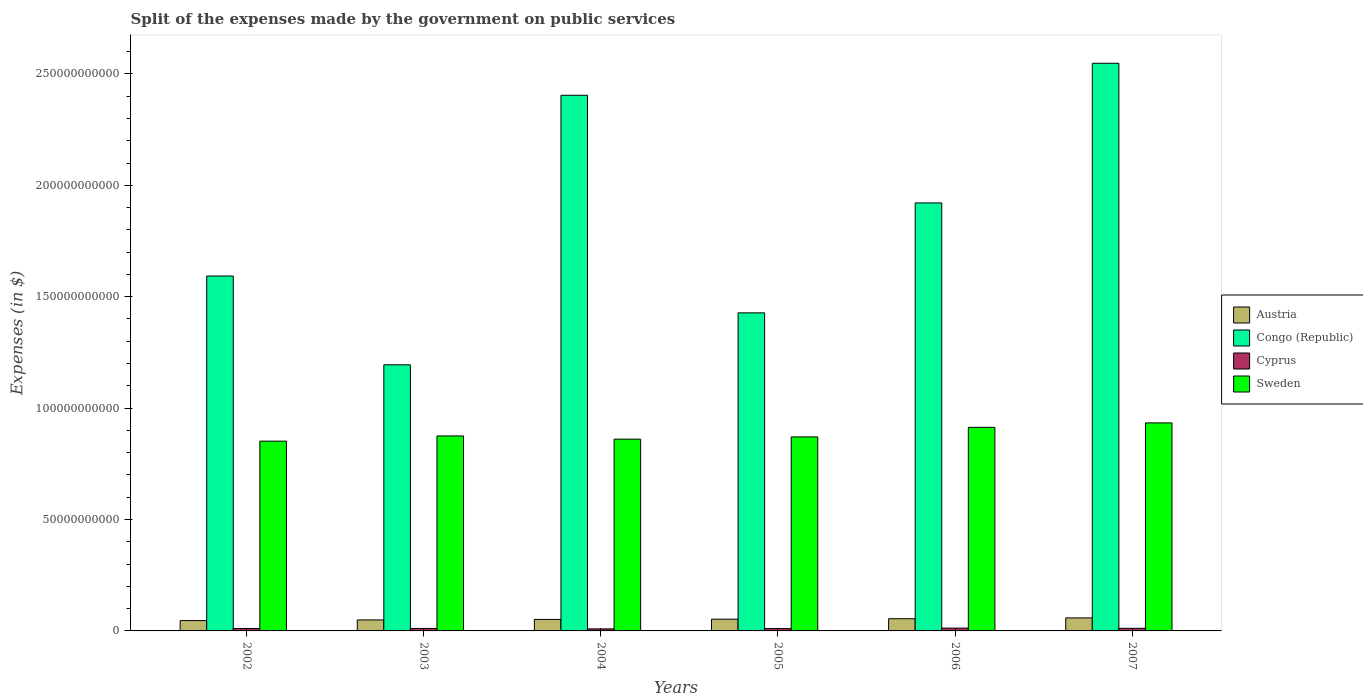How many different coloured bars are there?
Your response must be concise. 4. Are the number of bars on each tick of the X-axis equal?
Offer a very short reply. Yes. How many bars are there on the 1st tick from the left?
Provide a short and direct response. 4. What is the label of the 1st group of bars from the left?
Offer a terse response. 2002. What is the expenses made by the government on public services in Sweden in 2002?
Provide a succinct answer. 8.52e+1. Across all years, what is the maximum expenses made by the government on public services in Congo (Republic)?
Offer a terse response. 2.55e+11. Across all years, what is the minimum expenses made by the government on public services in Austria?
Provide a short and direct response. 4.65e+09. In which year was the expenses made by the government on public services in Austria minimum?
Keep it short and to the point. 2002. What is the total expenses made by the government on public services in Cyprus in the graph?
Provide a succinct answer. 6.59e+09. What is the difference between the expenses made by the government on public services in Cyprus in 2005 and that in 2006?
Your answer should be very brief. -2.13e+08. What is the difference between the expenses made by the government on public services in Cyprus in 2005 and the expenses made by the government on public services in Austria in 2004?
Offer a very short reply. -4.11e+09. What is the average expenses made by the government on public services in Congo (Republic) per year?
Provide a succinct answer. 1.85e+11. In the year 2004, what is the difference between the expenses made by the government on public services in Sweden and expenses made by the government on public services in Cyprus?
Make the answer very short. 8.51e+1. In how many years, is the expenses made by the government on public services in Cyprus greater than 110000000000 $?
Your answer should be compact. 0. What is the ratio of the expenses made by the government on public services in Sweden in 2002 to that in 2004?
Make the answer very short. 0.99. What is the difference between the highest and the second highest expenses made by the government on public services in Congo (Republic)?
Offer a terse response. 1.44e+1. What is the difference between the highest and the lowest expenses made by the government on public services in Cyprus?
Your answer should be very brief. 3.38e+08. Is the sum of the expenses made by the government on public services in Cyprus in 2003 and 2006 greater than the maximum expenses made by the government on public services in Congo (Republic) across all years?
Your answer should be very brief. No. What does the 3rd bar from the left in 2007 represents?
Your response must be concise. Cyprus. What does the 1st bar from the right in 2007 represents?
Make the answer very short. Sweden. What is the difference between two consecutive major ticks on the Y-axis?
Provide a short and direct response. 5.00e+1. Does the graph contain any zero values?
Offer a very short reply. No. Where does the legend appear in the graph?
Offer a terse response. Center right. How many legend labels are there?
Provide a succinct answer. 4. How are the legend labels stacked?
Provide a short and direct response. Vertical. What is the title of the graph?
Provide a succinct answer. Split of the expenses made by the government on public services. What is the label or title of the X-axis?
Your answer should be compact. Years. What is the label or title of the Y-axis?
Keep it short and to the point. Expenses (in $). What is the Expenses (in $) of Austria in 2002?
Offer a very short reply. 4.65e+09. What is the Expenses (in $) of Congo (Republic) in 2002?
Your answer should be compact. 1.59e+11. What is the Expenses (in $) of Cyprus in 2002?
Offer a terse response. 1.07e+09. What is the Expenses (in $) of Sweden in 2002?
Offer a very short reply. 8.52e+1. What is the Expenses (in $) in Austria in 2003?
Keep it short and to the point. 4.93e+09. What is the Expenses (in $) of Congo (Republic) in 2003?
Keep it short and to the point. 1.19e+11. What is the Expenses (in $) in Cyprus in 2003?
Provide a succinct answer. 1.11e+09. What is the Expenses (in $) of Sweden in 2003?
Keep it short and to the point. 8.75e+1. What is the Expenses (in $) of Austria in 2004?
Your answer should be very brief. 5.16e+09. What is the Expenses (in $) of Congo (Republic) in 2004?
Ensure brevity in your answer.  2.40e+11. What is the Expenses (in $) in Cyprus in 2004?
Give a very brief answer. 9.25e+08. What is the Expenses (in $) of Sweden in 2004?
Your response must be concise. 8.61e+1. What is the Expenses (in $) of Austria in 2005?
Your answer should be very brief. 5.27e+09. What is the Expenses (in $) in Congo (Republic) in 2005?
Give a very brief answer. 1.43e+11. What is the Expenses (in $) of Cyprus in 2005?
Provide a succinct answer. 1.05e+09. What is the Expenses (in $) of Sweden in 2005?
Your answer should be compact. 8.71e+1. What is the Expenses (in $) in Austria in 2006?
Make the answer very short. 5.48e+09. What is the Expenses (in $) in Congo (Republic) in 2006?
Keep it short and to the point. 1.92e+11. What is the Expenses (in $) in Cyprus in 2006?
Offer a terse response. 1.26e+09. What is the Expenses (in $) of Sweden in 2006?
Offer a terse response. 9.14e+1. What is the Expenses (in $) in Austria in 2007?
Your answer should be very brief. 5.84e+09. What is the Expenses (in $) of Congo (Republic) in 2007?
Provide a short and direct response. 2.55e+11. What is the Expenses (in $) of Cyprus in 2007?
Keep it short and to the point. 1.17e+09. What is the Expenses (in $) in Sweden in 2007?
Make the answer very short. 9.34e+1. Across all years, what is the maximum Expenses (in $) in Austria?
Give a very brief answer. 5.84e+09. Across all years, what is the maximum Expenses (in $) in Congo (Republic)?
Your answer should be very brief. 2.55e+11. Across all years, what is the maximum Expenses (in $) in Cyprus?
Your answer should be compact. 1.26e+09. Across all years, what is the maximum Expenses (in $) in Sweden?
Your response must be concise. 9.34e+1. Across all years, what is the minimum Expenses (in $) in Austria?
Your answer should be compact. 4.65e+09. Across all years, what is the minimum Expenses (in $) of Congo (Republic)?
Offer a very short reply. 1.19e+11. Across all years, what is the minimum Expenses (in $) of Cyprus?
Provide a succinct answer. 9.25e+08. Across all years, what is the minimum Expenses (in $) of Sweden?
Your answer should be very brief. 8.52e+1. What is the total Expenses (in $) in Austria in the graph?
Give a very brief answer. 3.13e+1. What is the total Expenses (in $) of Congo (Republic) in the graph?
Ensure brevity in your answer.  1.11e+12. What is the total Expenses (in $) of Cyprus in the graph?
Provide a succinct answer. 6.59e+09. What is the total Expenses (in $) in Sweden in the graph?
Provide a succinct answer. 5.31e+11. What is the difference between the Expenses (in $) in Austria in 2002 and that in 2003?
Provide a succinct answer. -2.86e+08. What is the difference between the Expenses (in $) in Congo (Republic) in 2002 and that in 2003?
Your response must be concise. 3.99e+1. What is the difference between the Expenses (in $) of Cyprus in 2002 and that in 2003?
Your answer should be compact. -3.13e+07. What is the difference between the Expenses (in $) in Sweden in 2002 and that in 2003?
Provide a short and direct response. -2.34e+09. What is the difference between the Expenses (in $) in Austria in 2002 and that in 2004?
Ensure brevity in your answer.  -5.13e+08. What is the difference between the Expenses (in $) in Congo (Republic) in 2002 and that in 2004?
Make the answer very short. -8.11e+1. What is the difference between the Expenses (in $) of Cyprus in 2002 and that in 2004?
Your response must be concise. 1.49e+08. What is the difference between the Expenses (in $) of Sweden in 2002 and that in 2004?
Make the answer very short. -9.00e+08. What is the difference between the Expenses (in $) of Austria in 2002 and that in 2005?
Offer a terse response. -6.18e+08. What is the difference between the Expenses (in $) in Congo (Republic) in 2002 and that in 2005?
Provide a succinct answer. 1.65e+1. What is the difference between the Expenses (in $) of Cyprus in 2002 and that in 2005?
Ensure brevity in your answer.  2.39e+07. What is the difference between the Expenses (in $) in Sweden in 2002 and that in 2005?
Offer a very short reply. -1.90e+09. What is the difference between the Expenses (in $) in Austria in 2002 and that in 2006?
Ensure brevity in your answer.  -8.29e+08. What is the difference between the Expenses (in $) of Congo (Republic) in 2002 and that in 2006?
Your answer should be compact. -3.28e+1. What is the difference between the Expenses (in $) in Cyprus in 2002 and that in 2006?
Keep it short and to the point. -1.89e+08. What is the difference between the Expenses (in $) in Sweden in 2002 and that in 2006?
Keep it short and to the point. -6.20e+09. What is the difference between the Expenses (in $) in Austria in 2002 and that in 2007?
Offer a very short reply. -1.19e+09. What is the difference between the Expenses (in $) in Congo (Republic) in 2002 and that in 2007?
Provide a succinct answer. -9.55e+1. What is the difference between the Expenses (in $) of Cyprus in 2002 and that in 2007?
Keep it short and to the point. -9.72e+07. What is the difference between the Expenses (in $) in Sweden in 2002 and that in 2007?
Make the answer very short. -8.19e+09. What is the difference between the Expenses (in $) of Austria in 2003 and that in 2004?
Make the answer very short. -2.27e+08. What is the difference between the Expenses (in $) in Congo (Republic) in 2003 and that in 2004?
Your answer should be compact. -1.21e+11. What is the difference between the Expenses (in $) in Cyprus in 2003 and that in 2004?
Your answer should be compact. 1.80e+08. What is the difference between the Expenses (in $) of Sweden in 2003 and that in 2004?
Give a very brief answer. 1.44e+09. What is the difference between the Expenses (in $) of Austria in 2003 and that in 2005?
Keep it short and to the point. -3.33e+08. What is the difference between the Expenses (in $) of Congo (Republic) in 2003 and that in 2005?
Your response must be concise. -2.33e+1. What is the difference between the Expenses (in $) in Cyprus in 2003 and that in 2005?
Make the answer very short. 5.52e+07. What is the difference between the Expenses (in $) of Sweden in 2003 and that in 2005?
Offer a terse response. 4.36e+08. What is the difference between the Expenses (in $) in Austria in 2003 and that in 2006?
Offer a very short reply. -5.44e+08. What is the difference between the Expenses (in $) of Congo (Republic) in 2003 and that in 2006?
Provide a succinct answer. -7.27e+1. What is the difference between the Expenses (in $) of Cyprus in 2003 and that in 2006?
Provide a succinct answer. -1.57e+08. What is the difference between the Expenses (in $) in Sweden in 2003 and that in 2006?
Offer a very short reply. -3.86e+09. What is the difference between the Expenses (in $) in Austria in 2003 and that in 2007?
Provide a succinct answer. -9.08e+08. What is the difference between the Expenses (in $) of Congo (Republic) in 2003 and that in 2007?
Provide a succinct answer. -1.35e+11. What is the difference between the Expenses (in $) of Cyprus in 2003 and that in 2007?
Give a very brief answer. -6.60e+07. What is the difference between the Expenses (in $) in Sweden in 2003 and that in 2007?
Make the answer very short. -5.86e+09. What is the difference between the Expenses (in $) in Austria in 2004 and that in 2005?
Keep it short and to the point. -1.06e+08. What is the difference between the Expenses (in $) in Congo (Republic) in 2004 and that in 2005?
Your answer should be compact. 9.77e+1. What is the difference between the Expenses (in $) of Cyprus in 2004 and that in 2005?
Provide a short and direct response. -1.25e+08. What is the difference between the Expenses (in $) in Sweden in 2004 and that in 2005?
Offer a very short reply. -1.00e+09. What is the difference between the Expenses (in $) in Austria in 2004 and that in 2006?
Give a very brief answer. -3.17e+08. What is the difference between the Expenses (in $) of Congo (Republic) in 2004 and that in 2006?
Your answer should be very brief. 4.83e+1. What is the difference between the Expenses (in $) of Cyprus in 2004 and that in 2006?
Ensure brevity in your answer.  -3.38e+08. What is the difference between the Expenses (in $) of Sweden in 2004 and that in 2006?
Ensure brevity in your answer.  -5.30e+09. What is the difference between the Expenses (in $) of Austria in 2004 and that in 2007?
Your answer should be compact. -6.81e+08. What is the difference between the Expenses (in $) of Congo (Republic) in 2004 and that in 2007?
Your answer should be very brief. -1.44e+1. What is the difference between the Expenses (in $) of Cyprus in 2004 and that in 2007?
Your answer should be compact. -2.46e+08. What is the difference between the Expenses (in $) in Sweden in 2004 and that in 2007?
Keep it short and to the point. -7.29e+09. What is the difference between the Expenses (in $) in Austria in 2005 and that in 2006?
Give a very brief answer. -2.11e+08. What is the difference between the Expenses (in $) of Congo (Republic) in 2005 and that in 2006?
Keep it short and to the point. -4.94e+1. What is the difference between the Expenses (in $) of Cyprus in 2005 and that in 2006?
Offer a very short reply. -2.13e+08. What is the difference between the Expenses (in $) of Sweden in 2005 and that in 2006?
Make the answer very short. -4.30e+09. What is the difference between the Expenses (in $) of Austria in 2005 and that in 2007?
Provide a short and direct response. -5.75e+08. What is the difference between the Expenses (in $) in Congo (Republic) in 2005 and that in 2007?
Provide a succinct answer. -1.12e+11. What is the difference between the Expenses (in $) of Cyprus in 2005 and that in 2007?
Keep it short and to the point. -1.21e+08. What is the difference between the Expenses (in $) in Sweden in 2005 and that in 2007?
Your answer should be very brief. -6.29e+09. What is the difference between the Expenses (in $) in Austria in 2006 and that in 2007?
Your answer should be very brief. -3.64e+08. What is the difference between the Expenses (in $) of Congo (Republic) in 2006 and that in 2007?
Your answer should be very brief. -6.27e+1. What is the difference between the Expenses (in $) in Cyprus in 2006 and that in 2007?
Offer a very short reply. 9.14e+07. What is the difference between the Expenses (in $) in Sweden in 2006 and that in 2007?
Offer a terse response. -2.00e+09. What is the difference between the Expenses (in $) in Austria in 2002 and the Expenses (in $) in Congo (Republic) in 2003?
Your answer should be compact. -1.15e+11. What is the difference between the Expenses (in $) of Austria in 2002 and the Expenses (in $) of Cyprus in 2003?
Your answer should be very brief. 3.54e+09. What is the difference between the Expenses (in $) in Austria in 2002 and the Expenses (in $) in Sweden in 2003?
Your response must be concise. -8.29e+1. What is the difference between the Expenses (in $) in Congo (Republic) in 2002 and the Expenses (in $) in Cyprus in 2003?
Your answer should be compact. 1.58e+11. What is the difference between the Expenses (in $) in Congo (Republic) in 2002 and the Expenses (in $) in Sweden in 2003?
Provide a succinct answer. 7.18e+1. What is the difference between the Expenses (in $) of Cyprus in 2002 and the Expenses (in $) of Sweden in 2003?
Offer a very short reply. -8.64e+1. What is the difference between the Expenses (in $) of Austria in 2002 and the Expenses (in $) of Congo (Republic) in 2004?
Offer a terse response. -2.36e+11. What is the difference between the Expenses (in $) in Austria in 2002 and the Expenses (in $) in Cyprus in 2004?
Keep it short and to the point. 3.72e+09. What is the difference between the Expenses (in $) of Austria in 2002 and the Expenses (in $) of Sweden in 2004?
Offer a terse response. -8.14e+1. What is the difference between the Expenses (in $) in Congo (Republic) in 2002 and the Expenses (in $) in Cyprus in 2004?
Your response must be concise. 1.58e+11. What is the difference between the Expenses (in $) of Congo (Republic) in 2002 and the Expenses (in $) of Sweden in 2004?
Ensure brevity in your answer.  7.32e+1. What is the difference between the Expenses (in $) in Cyprus in 2002 and the Expenses (in $) in Sweden in 2004?
Offer a very short reply. -8.50e+1. What is the difference between the Expenses (in $) of Austria in 2002 and the Expenses (in $) of Congo (Republic) in 2005?
Your answer should be compact. -1.38e+11. What is the difference between the Expenses (in $) of Austria in 2002 and the Expenses (in $) of Cyprus in 2005?
Offer a very short reply. 3.60e+09. What is the difference between the Expenses (in $) in Austria in 2002 and the Expenses (in $) in Sweden in 2005?
Keep it short and to the point. -8.24e+1. What is the difference between the Expenses (in $) of Congo (Republic) in 2002 and the Expenses (in $) of Cyprus in 2005?
Offer a very short reply. 1.58e+11. What is the difference between the Expenses (in $) of Congo (Republic) in 2002 and the Expenses (in $) of Sweden in 2005?
Your response must be concise. 7.22e+1. What is the difference between the Expenses (in $) of Cyprus in 2002 and the Expenses (in $) of Sweden in 2005?
Your answer should be compact. -8.60e+1. What is the difference between the Expenses (in $) of Austria in 2002 and the Expenses (in $) of Congo (Republic) in 2006?
Offer a very short reply. -1.87e+11. What is the difference between the Expenses (in $) in Austria in 2002 and the Expenses (in $) in Cyprus in 2006?
Keep it short and to the point. 3.39e+09. What is the difference between the Expenses (in $) in Austria in 2002 and the Expenses (in $) in Sweden in 2006?
Give a very brief answer. -8.67e+1. What is the difference between the Expenses (in $) of Congo (Republic) in 2002 and the Expenses (in $) of Cyprus in 2006?
Provide a succinct answer. 1.58e+11. What is the difference between the Expenses (in $) in Congo (Republic) in 2002 and the Expenses (in $) in Sweden in 2006?
Give a very brief answer. 6.79e+1. What is the difference between the Expenses (in $) in Cyprus in 2002 and the Expenses (in $) in Sweden in 2006?
Ensure brevity in your answer.  -9.03e+1. What is the difference between the Expenses (in $) in Austria in 2002 and the Expenses (in $) in Congo (Republic) in 2007?
Ensure brevity in your answer.  -2.50e+11. What is the difference between the Expenses (in $) in Austria in 2002 and the Expenses (in $) in Cyprus in 2007?
Provide a short and direct response. 3.48e+09. What is the difference between the Expenses (in $) of Austria in 2002 and the Expenses (in $) of Sweden in 2007?
Ensure brevity in your answer.  -8.87e+1. What is the difference between the Expenses (in $) of Congo (Republic) in 2002 and the Expenses (in $) of Cyprus in 2007?
Give a very brief answer. 1.58e+11. What is the difference between the Expenses (in $) of Congo (Republic) in 2002 and the Expenses (in $) of Sweden in 2007?
Provide a succinct answer. 6.59e+1. What is the difference between the Expenses (in $) in Cyprus in 2002 and the Expenses (in $) in Sweden in 2007?
Your answer should be compact. -9.23e+1. What is the difference between the Expenses (in $) in Austria in 2003 and the Expenses (in $) in Congo (Republic) in 2004?
Your response must be concise. -2.35e+11. What is the difference between the Expenses (in $) of Austria in 2003 and the Expenses (in $) of Cyprus in 2004?
Your answer should be very brief. 4.01e+09. What is the difference between the Expenses (in $) of Austria in 2003 and the Expenses (in $) of Sweden in 2004?
Your answer should be compact. -8.11e+1. What is the difference between the Expenses (in $) of Congo (Republic) in 2003 and the Expenses (in $) of Cyprus in 2004?
Your answer should be compact. 1.19e+11. What is the difference between the Expenses (in $) of Congo (Republic) in 2003 and the Expenses (in $) of Sweden in 2004?
Your response must be concise. 3.34e+1. What is the difference between the Expenses (in $) of Cyprus in 2003 and the Expenses (in $) of Sweden in 2004?
Offer a very short reply. -8.50e+1. What is the difference between the Expenses (in $) in Austria in 2003 and the Expenses (in $) in Congo (Republic) in 2005?
Your response must be concise. -1.38e+11. What is the difference between the Expenses (in $) of Austria in 2003 and the Expenses (in $) of Cyprus in 2005?
Your answer should be compact. 3.88e+09. What is the difference between the Expenses (in $) in Austria in 2003 and the Expenses (in $) in Sweden in 2005?
Make the answer very short. -8.21e+1. What is the difference between the Expenses (in $) in Congo (Republic) in 2003 and the Expenses (in $) in Cyprus in 2005?
Offer a terse response. 1.18e+11. What is the difference between the Expenses (in $) in Congo (Republic) in 2003 and the Expenses (in $) in Sweden in 2005?
Give a very brief answer. 3.24e+1. What is the difference between the Expenses (in $) of Cyprus in 2003 and the Expenses (in $) of Sweden in 2005?
Provide a short and direct response. -8.60e+1. What is the difference between the Expenses (in $) of Austria in 2003 and the Expenses (in $) of Congo (Republic) in 2006?
Offer a very short reply. -1.87e+11. What is the difference between the Expenses (in $) in Austria in 2003 and the Expenses (in $) in Cyprus in 2006?
Your answer should be compact. 3.67e+09. What is the difference between the Expenses (in $) in Austria in 2003 and the Expenses (in $) in Sweden in 2006?
Keep it short and to the point. -8.64e+1. What is the difference between the Expenses (in $) of Congo (Republic) in 2003 and the Expenses (in $) of Cyprus in 2006?
Your answer should be very brief. 1.18e+11. What is the difference between the Expenses (in $) of Congo (Republic) in 2003 and the Expenses (in $) of Sweden in 2006?
Provide a short and direct response. 2.81e+1. What is the difference between the Expenses (in $) of Cyprus in 2003 and the Expenses (in $) of Sweden in 2006?
Your response must be concise. -9.03e+1. What is the difference between the Expenses (in $) in Austria in 2003 and the Expenses (in $) in Congo (Republic) in 2007?
Provide a succinct answer. -2.50e+11. What is the difference between the Expenses (in $) of Austria in 2003 and the Expenses (in $) of Cyprus in 2007?
Ensure brevity in your answer.  3.76e+09. What is the difference between the Expenses (in $) of Austria in 2003 and the Expenses (in $) of Sweden in 2007?
Ensure brevity in your answer.  -8.84e+1. What is the difference between the Expenses (in $) of Congo (Republic) in 2003 and the Expenses (in $) of Cyprus in 2007?
Your answer should be very brief. 1.18e+11. What is the difference between the Expenses (in $) of Congo (Republic) in 2003 and the Expenses (in $) of Sweden in 2007?
Give a very brief answer. 2.61e+1. What is the difference between the Expenses (in $) of Cyprus in 2003 and the Expenses (in $) of Sweden in 2007?
Make the answer very short. -9.23e+1. What is the difference between the Expenses (in $) of Austria in 2004 and the Expenses (in $) of Congo (Republic) in 2005?
Give a very brief answer. -1.38e+11. What is the difference between the Expenses (in $) of Austria in 2004 and the Expenses (in $) of Cyprus in 2005?
Your answer should be very brief. 4.11e+09. What is the difference between the Expenses (in $) of Austria in 2004 and the Expenses (in $) of Sweden in 2005?
Offer a very short reply. -8.19e+1. What is the difference between the Expenses (in $) in Congo (Republic) in 2004 and the Expenses (in $) in Cyprus in 2005?
Offer a very short reply. 2.39e+11. What is the difference between the Expenses (in $) of Congo (Republic) in 2004 and the Expenses (in $) of Sweden in 2005?
Ensure brevity in your answer.  1.53e+11. What is the difference between the Expenses (in $) of Cyprus in 2004 and the Expenses (in $) of Sweden in 2005?
Give a very brief answer. -8.61e+1. What is the difference between the Expenses (in $) of Austria in 2004 and the Expenses (in $) of Congo (Republic) in 2006?
Offer a very short reply. -1.87e+11. What is the difference between the Expenses (in $) of Austria in 2004 and the Expenses (in $) of Cyprus in 2006?
Provide a succinct answer. 3.90e+09. What is the difference between the Expenses (in $) of Austria in 2004 and the Expenses (in $) of Sweden in 2006?
Offer a very short reply. -8.62e+1. What is the difference between the Expenses (in $) in Congo (Republic) in 2004 and the Expenses (in $) in Cyprus in 2006?
Offer a very short reply. 2.39e+11. What is the difference between the Expenses (in $) in Congo (Republic) in 2004 and the Expenses (in $) in Sweden in 2006?
Ensure brevity in your answer.  1.49e+11. What is the difference between the Expenses (in $) of Cyprus in 2004 and the Expenses (in $) of Sweden in 2006?
Give a very brief answer. -9.04e+1. What is the difference between the Expenses (in $) of Austria in 2004 and the Expenses (in $) of Congo (Republic) in 2007?
Offer a very short reply. -2.50e+11. What is the difference between the Expenses (in $) of Austria in 2004 and the Expenses (in $) of Cyprus in 2007?
Keep it short and to the point. 3.99e+09. What is the difference between the Expenses (in $) of Austria in 2004 and the Expenses (in $) of Sweden in 2007?
Provide a succinct answer. -8.82e+1. What is the difference between the Expenses (in $) of Congo (Republic) in 2004 and the Expenses (in $) of Cyprus in 2007?
Make the answer very short. 2.39e+11. What is the difference between the Expenses (in $) in Congo (Republic) in 2004 and the Expenses (in $) in Sweden in 2007?
Offer a terse response. 1.47e+11. What is the difference between the Expenses (in $) in Cyprus in 2004 and the Expenses (in $) in Sweden in 2007?
Your answer should be very brief. -9.24e+1. What is the difference between the Expenses (in $) in Austria in 2005 and the Expenses (in $) in Congo (Republic) in 2006?
Your response must be concise. -1.87e+11. What is the difference between the Expenses (in $) in Austria in 2005 and the Expenses (in $) in Cyprus in 2006?
Your answer should be very brief. 4.00e+09. What is the difference between the Expenses (in $) of Austria in 2005 and the Expenses (in $) of Sweden in 2006?
Keep it short and to the point. -8.61e+1. What is the difference between the Expenses (in $) in Congo (Republic) in 2005 and the Expenses (in $) in Cyprus in 2006?
Offer a terse response. 1.41e+11. What is the difference between the Expenses (in $) of Congo (Republic) in 2005 and the Expenses (in $) of Sweden in 2006?
Keep it short and to the point. 5.14e+1. What is the difference between the Expenses (in $) in Cyprus in 2005 and the Expenses (in $) in Sweden in 2006?
Your answer should be compact. -9.03e+1. What is the difference between the Expenses (in $) of Austria in 2005 and the Expenses (in $) of Congo (Republic) in 2007?
Your answer should be very brief. -2.50e+11. What is the difference between the Expenses (in $) in Austria in 2005 and the Expenses (in $) in Cyprus in 2007?
Ensure brevity in your answer.  4.10e+09. What is the difference between the Expenses (in $) in Austria in 2005 and the Expenses (in $) in Sweden in 2007?
Give a very brief answer. -8.81e+1. What is the difference between the Expenses (in $) in Congo (Republic) in 2005 and the Expenses (in $) in Cyprus in 2007?
Keep it short and to the point. 1.42e+11. What is the difference between the Expenses (in $) of Congo (Republic) in 2005 and the Expenses (in $) of Sweden in 2007?
Your answer should be compact. 4.94e+1. What is the difference between the Expenses (in $) in Cyprus in 2005 and the Expenses (in $) in Sweden in 2007?
Offer a very short reply. -9.23e+1. What is the difference between the Expenses (in $) of Austria in 2006 and the Expenses (in $) of Congo (Republic) in 2007?
Provide a succinct answer. -2.49e+11. What is the difference between the Expenses (in $) of Austria in 2006 and the Expenses (in $) of Cyprus in 2007?
Make the answer very short. 4.31e+09. What is the difference between the Expenses (in $) of Austria in 2006 and the Expenses (in $) of Sweden in 2007?
Your response must be concise. -8.79e+1. What is the difference between the Expenses (in $) in Congo (Republic) in 2006 and the Expenses (in $) in Cyprus in 2007?
Offer a very short reply. 1.91e+11. What is the difference between the Expenses (in $) of Congo (Republic) in 2006 and the Expenses (in $) of Sweden in 2007?
Give a very brief answer. 9.87e+1. What is the difference between the Expenses (in $) in Cyprus in 2006 and the Expenses (in $) in Sweden in 2007?
Give a very brief answer. -9.21e+1. What is the average Expenses (in $) in Austria per year?
Your answer should be very brief. 5.22e+09. What is the average Expenses (in $) in Congo (Republic) per year?
Keep it short and to the point. 1.85e+11. What is the average Expenses (in $) of Cyprus per year?
Your answer should be compact. 1.10e+09. What is the average Expenses (in $) of Sweden per year?
Provide a short and direct response. 8.84e+1. In the year 2002, what is the difference between the Expenses (in $) of Austria and Expenses (in $) of Congo (Republic)?
Offer a terse response. -1.55e+11. In the year 2002, what is the difference between the Expenses (in $) in Austria and Expenses (in $) in Cyprus?
Your answer should be compact. 3.57e+09. In the year 2002, what is the difference between the Expenses (in $) in Austria and Expenses (in $) in Sweden?
Your answer should be very brief. -8.05e+1. In the year 2002, what is the difference between the Expenses (in $) in Congo (Republic) and Expenses (in $) in Cyprus?
Give a very brief answer. 1.58e+11. In the year 2002, what is the difference between the Expenses (in $) of Congo (Republic) and Expenses (in $) of Sweden?
Give a very brief answer. 7.41e+1. In the year 2002, what is the difference between the Expenses (in $) in Cyprus and Expenses (in $) in Sweden?
Ensure brevity in your answer.  -8.41e+1. In the year 2003, what is the difference between the Expenses (in $) of Austria and Expenses (in $) of Congo (Republic)?
Give a very brief answer. -1.15e+11. In the year 2003, what is the difference between the Expenses (in $) in Austria and Expenses (in $) in Cyprus?
Your response must be concise. 3.83e+09. In the year 2003, what is the difference between the Expenses (in $) in Austria and Expenses (in $) in Sweden?
Make the answer very short. -8.26e+1. In the year 2003, what is the difference between the Expenses (in $) in Congo (Republic) and Expenses (in $) in Cyprus?
Provide a short and direct response. 1.18e+11. In the year 2003, what is the difference between the Expenses (in $) of Congo (Republic) and Expenses (in $) of Sweden?
Offer a terse response. 3.19e+1. In the year 2003, what is the difference between the Expenses (in $) in Cyprus and Expenses (in $) in Sweden?
Offer a very short reply. -8.64e+1. In the year 2004, what is the difference between the Expenses (in $) in Austria and Expenses (in $) in Congo (Republic)?
Offer a very short reply. -2.35e+11. In the year 2004, what is the difference between the Expenses (in $) of Austria and Expenses (in $) of Cyprus?
Offer a very short reply. 4.24e+09. In the year 2004, what is the difference between the Expenses (in $) of Austria and Expenses (in $) of Sweden?
Offer a very short reply. -8.09e+1. In the year 2004, what is the difference between the Expenses (in $) of Congo (Republic) and Expenses (in $) of Cyprus?
Provide a short and direct response. 2.39e+11. In the year 2004, what is the difference between the Expenses (in $) in Congo (Republic) and Expenses (in $) in Sweden?
Give a very brief answer. 1.54e+11. In the year 2004, what is the difference between the Expenses (in $) of Cyprus and Expenses (in $) of Sweden?
Offer a very short reply. -8.51e+1. In the year 2005, what is the difference between the Expenses (in $) in Austria and Expenses (in $) in Congo (Republic)?
Give a very brief answer. -1.37e+11. In the year 2005, what is the difference between the Expenses (in $) in Austria and Expenses (in $) in Cyprus?
Provide a short and direct response. 4.22e+09. In the year 2005, what is the difference between the Expenses (in $) in Austria and Expenses (in $) in Sweden?
Give a very brief answer. -8.18e+1. In the year 2005, what is the difference between the Expenses (in $) of Congo (Republic) and Expenses (in $) of Cyprus?
Ensure brevity in your answer.  1.42e+11. In the year 2005, what is the difference between the Expenses (in $) of Congo (Republic) and Expenses (in $) of Sweden?
Keep it short and to the point. 5.57e+1. In the year 2005, what is the difference between the Expenses (in $) in Cyprus and Expenses (in $) in Sweden?
Give a very brief answer. -8.60e+1. In the year 2006, what is the difference between the Expenses (in $) of Austria and Expenses (in $) of Congo (Republic)?
Offer a terse response. -1.87e+11. In the year 2006, what is the difference between the Expenses (in $) of Austria and Expenses (in $) of Cyprus?
Keep it short and to the point. 4.22e+09. In the year 2006, what is the difference between the Expenses (in $) in Austria and Expenses (in $) in Sweden?
Provide a succinct answer. -8.59e+1. In the year 2006, what is the difference between the Expenses (in $) in Congo (Republic) and Expenses (in $) in Cyprus?
Keep it short and to the point. 1.91e+11. In the year 2006, what is the difference between the Expenses (in $) in Congo (Republic) and Expenses (in $) in Sweden?
Make the answer very short. 1.01e+11. In the year 2006, what is the difference between the Expenses (in $) of Cyprus and Expenses (in $) of Sweden?
Offer a terse response. -9.01e+1. In the year 2007, what is the difference between the Expenses (in $) in Austria and Expenses (in $) in Congo (Republic)?
Provide a short and direct response. -2.49e+11. In the year 2007, what is the difference between the Expenses (in $) of Austria and Expenses (in $) of Cyprus?
Provide a succinct answer. 4.67e+09. In the year 2007, what is the difference between the Expenses (in $) of Austria and Expenses (in $) of Sweden?
Provide a short and direct response. -8.75e+1. In the year 2007, what is the difference between the Expenses (in $) of Congo (Republic) and Expenses (in $) of Cyprus?
Offer a very short reply. 2.54e+11. In the year 2007, what is the difference between the Expenses (in $) of Congo (Republic) and Expenses (in $) of Sweden?
Your answer should be very brief. 1.61e+11. In the year 2007, what is the difference between the Expenses (in $) in Cyprus and Expenses (in $) in Sweden?
Your response must be concise. -9.22e+1. What is the ratio of the Expenses (in $) of Austria in 2002 to that in 2003?
Keep it short and to the point. 0.94. What is the ratio of the Expenses (in $) in Congo (Republic) in 2002 to that in 2003?
Your answer should be very brief. 1.33. What is the ratio of the Expenses (in $) in Cyprus in 2002 to that in 2003?
Your response must be concise. 0.97. What is the ratio of the Expenses (in $) of Sweden in 2002 to that in 2003?
Your response must be concise. 0.97. What is the ratio of the Expenses (in $) of Austria in 2002 to that in 2004?
Provide a short and direct response. 0.9. What is the ratio of the Expenses (in $) of Congo (Republic) in 2002 to that in 2004?
Your response must be concise. 0.66. What is the ratio of the Expenses (in $) of Cyprus in 2002 to that in 2004?
Your response must be concise. 1.16. What is the ratio of the Expenses (in $) of Sweden in 2002 to that in 2004?
Keep it short and to the point. 0.99. What is the ratio of the Expenses (in $) of Austria in 2002 to that in 2005?
Provide a short and direct response. 0.88. What is the ratio of the Expenses (in $) of Congo (Republic) in 2002 to that in 2005?
Your response must be concise. 1.12. What is the ratio of the Expenses (in $) in Cyprus in 2002 to that in 2005?
Offer a terse response. 1.02. What is the ratio of the Expenses (in $) in Sweden in 2002 to that in 2005?
Offer a terse response. 0.98. What is the ratio of the Expenses (in $) in Austria in 2002 to that in 2006?
Give a very brief answer. 0.85. What is the ratio of the Expenses (in $) of Congo (Republic) in 2002 to that in 2006?
Provide a short and direct response. 0.83. What is the ratio of the Expenses (in $) of Cyprus in 2002 to that in 2006?
Your answer should be very brief. 0.85. What is the ratio of the Expenses (in $) in Sweden in 2002 to that in 2006?
Your answer should be very brief. 0.93. What is the ratio of the Expenses (in $) of Austria in 2002 to that in 2007?
Give a very brief answer. 0.8. What is the ratio of the Expenses (in $) in Congo (Republic) in 2002 to that in 2007?
Make the answer very short. 0.63. What is the ratio of the Expenses (in $) in Cyprus in 2002 to that in 2007?
Give a very brief answer. 0.92. What is the ratio of the Expenses (in $) in Sweden in 2002 to that in 2007?
Keep it short and to the point. 0.91. What is the ratio of the Expenses (in $) of Austria in 2003 to that in 2004?
Make the answer very short. 0.96. What is the ratio of the Expenses (in $) in Congo (Republic) in 2003 to that in 2004?
Make the answer very short. 0.5. What is the ratio of the Expenses (in $) in Cyprus in 2003 to that in 2004?
Ensure brevity in your answer.  1.19. What is the ratio of the Expenses (in $) of Sweden in 2003 to that in 2004?
Make the answer very short. 1.02. What is the ratio of the Expenses (in $) in Austria in 2003 to that in 2005?
Your response must be concise. 0.94. What is the ratio of the Expenses (in $) in Congo (Republic) in 2003 to that in 2005?
Offer a very short reply. 0.84. What is the ratio of the Expenses (in $) of Cyprus in 2003 to that in 2005?
Offer a terse response. 1.05. What is the ratio of the Expenses (in $) in Austria in 2003 to that in 2006?
Ensure brevity in your answer.  0.9. What is the ratio of the Expenses (in $) of Congo (Republic) in 2003 to that in 2006?
Offer a very short reply. 0.62. What is the ratio of the Expenses (in $) in Cyprus in 2003 to that in 2006?
Provide a succinct answer. 0.88. What is the ratio of the Expenses (in $) in Sweden in 2003 to that in 2006?
Provide a short and direct response. 0.96. What is the ratio of the Expenses (in $) in Austria in 2003 to that in 2007?
Your answer should be very brief. 0.84. What is the ratio of the Expenses (in $) of Congo (Republic) in 2003 to that in 2007?
Your answer should be very brief. 0.47. What is the ratio of the Expenses (in $) in Cyprus in 2003 to that in 2007?
Make the answer very short. 0.94. What is the ratio of the Expenses (in $) in Sweden in 2003 to that in 2007?
Give a very brief answer. 0.94. What is the ratio of the Expenses (in $) in Austria in 2004 to that in 2005?
Your answer should be very brief. 0.98. What is the ratio of the Expenses (in $) in Congo (Republic) in 2004 to that in 2005?
Give a very brief answer. 1.68. What is the ratio of the Expenses (in $) of Cyprus in 2004 to that in 2005?
Ensure brevity in your answer.  0.88. What is the ratio of the Expenses (in $) of Sweden in 2004 to that in 2005?
Your answer should be very brief. 0.99. What is the ratio of the Expenses (in $) of Austria in 2004 to that in 2006?
Provide a succinct answer. 0.94. What is the ratio of the Expenses (in $) of Congo (Republic) in 2004 to that in 2006?
Your response must be concise. 1.25. What is the ratio of the Expenses (in $) in Cyprus in 2004 to that in 2006?
Make the answer very short. 0.73. What is the ratio of the Expenses (in $) in Sweden in 2004 to that in 2006?
Ensure brevity in your answer.  0.94. What is the ratio of the Expenses (in $) of Austria in 2004 to that in 2007?
Your answer should be very brief. 0.88. What is the ratio of the Expenses (in $) in Congo (Republic) in 2004 to that in 2007?
Your answer should be very brief. 0.94. What is the ratio of the Expenses (in $) of Cyprus in 2004 to that in 2007?
Your response must be concise. 0.79. What is the ratio of the Expenses (in $) of Sweden in 2004 to that in 2007?
Offer a very short reply. 0.92. What is the ratio of the Expenses (in $) in Austria in 2005 to that in 2006?
Provide a succinct answer. 0.96. What is the ratio of the Expenses (in $) of Congo (Republic) in 2005 to that in 2006?
Offer a very short reply. 0.74. What is the ratio of the Expenses (in $) of Cyprus in 2005 to that in 2006?
Make the answer very short. 0.83. What is the ratio of the Expenses (in $) of Sweden in 2005 to that in 2006?
Ensure brevity in your answer.  0.95. What is the ratio of the Expenses (in $) in Austria in 2005 to that in 2007?
Give a very brief answer. 0.9. What is the ratio of the Expenses (in $) in Congo (Republic) in 2005 to that in 2007?
Ensure brevity in your answer.  0.56. What is the ratio of the Expenses (in $) in Cyprus in 2005 to that in 2007?
Provide a succinct answer. 0.9. What is the ratio of the Expenses (in $) in Sweden in 2005 to that in 2007?
Keep it short and to the point. 0.93. What is the ratio of the Expenses (in $) of Austria in 2006 to that in 2007?
Make the answer very short. 0.94. What is the ratio of the Expenses (in $) in Congo (Republic) in 2006 to that in 2007?
Ensure brevity in your answer.  0.75. What is the ratio of the Expenses (in $) of Cyprus in 2006 to that in 2007?
Ensure brevity in your answer.  1.08. What is the ratio of the Expenses (in $) of Sweden in 2006 to that in 2007?
Make the answer very short. 0.98. What is the difference between the highest and the second highest Expenses (in $) of Austria?
Give a very brief answer. 3.64e+08. What is the difference between the highest and the second highest Expenses (in $) of Congo (Republic)?
Provide a succinct answer. 1.44e+1. What is the difference between the highest and the second highest Expenses (in $) of Cyprus?
Provide a short and direct response. 9.14e+07. What is the difference between the highest and the second highest Expenses (in $) of Sweden?
Give a very brief answer. 2.00e+09. What is the difference between the highest and the lowest Expenses (in $) of Austria?
Your response must be concise. 1.19e+09. What is the difference between the highest and the lowest Expenses (in $) of Congo (Republic)?
Your answer should be very brief. 1.35e+11. What is the difference between the highest and the lowest Expenses (in $) of Cyprus?
Make the answer very short. 3.38e+08. What is the difference between the highest and the lowest Expenses (in $) in Sweden?
Your response must be concise. 8.19e+09. 